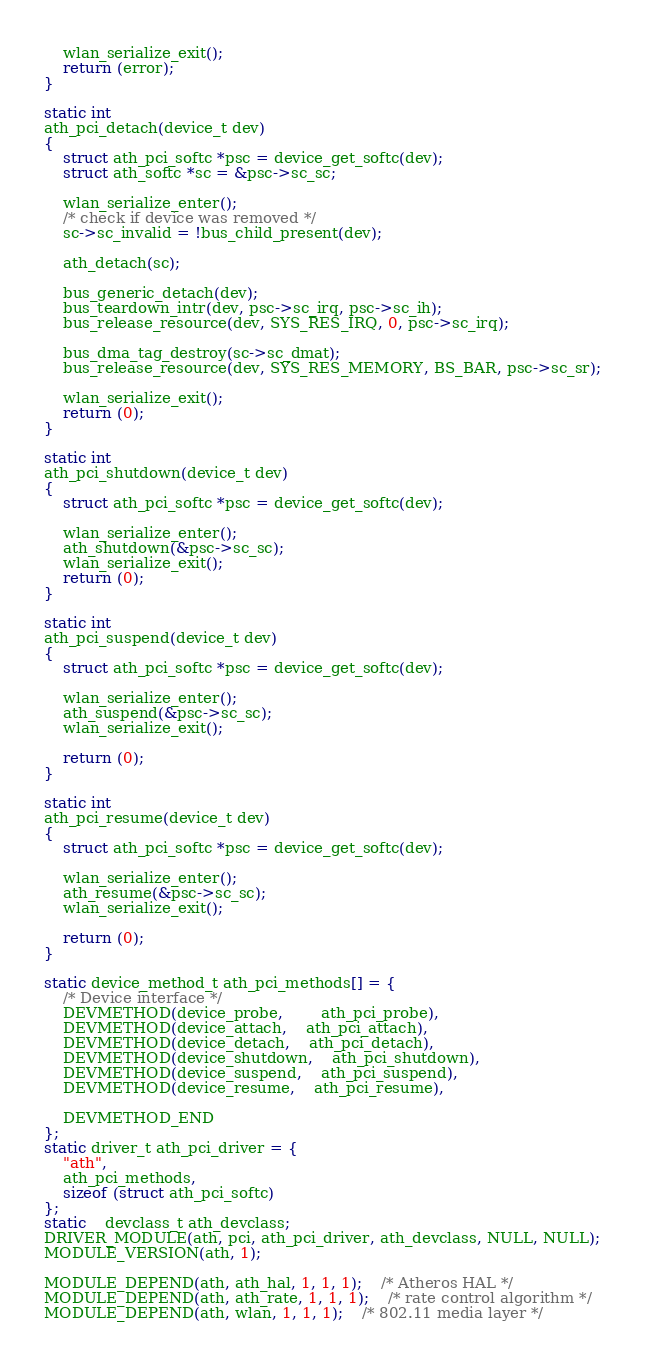Convert code to text. <code><loc_0><loc_0><loc_500><loc_500><_C_>	wlan_serialize_exit();
	return (error);
}

static int
ath_pci_detach(device_t dev)
{
	struct ath_pci_softc *psc = device_get_softc(dev);
	struct ath_softc *sc = &psc->sc_sc;

	wlan_serialize_enter();
	/* check if device was removed */
	sc->sc_invalid = !bus_child_present(dev);

	ath_detach(sc);

	bus_generic_detach(dev);
	bus_teardown_intr(dev, psc->sc_irq, psc->sc_ih);
	bus_release_resource(dev, SYS_RES_IRQ, 0, psc->sc_irq);

	bus_dma_tag_destroy(sc->sc_dmat);
	bus_release_resource(dev, SYS_RES_MEMORY, BS_BAR, psc->sc_sr);

	wlan_serialize_exit();
	return (0);
}

static int
ath_pci_shutdown(device_t dev)
{
	struct ath_pci_softc *psc = device_get_softc(dev);

	wlan_serialize_enter();
	ath_shutdown(&psc->sc_sc);
	wlan_serialize_exit();
	return (0);
}

static int
ath_pci_suspend(device_t dev)
{
	struct ath_pci_softc *psc = device_get_softc(dev);

	wlan_serialize_enter();
	ath_suspend(&psc->sc_sc);
	wlan_serialize_exit();

	return (0);
}

static int
ath_pci_resume(device_t dev)
{
	struct ath_pci_softc *psc = device_get_softc(dev);

	wlan_serialize_enter();
	ath_resume(&psc->sc_sc);
	wlan_serialize_exit();

	return (0);
}

static device_method_t ath_pci_methods[] = {
	/* Device interface */
	DEVMETHOD(device_probe,		ath_pci_probe),
	DEVMETHOD(device_attach,	ath_pci_attach),
	DEVMETHOD(device_detach,	ath_pci_detach),
	DEVMETHOD(device_shutdown,	ath_pci_shutdown),
	DEVMETHOD(device_suspend,	ath_pci_suspend),
	DEVMETHOD(device_resume,	ath_pci_resume),

	DEVMETHOD_END
};
static driver_t ath_pci_driver = {
	"ath",
	ath_pci_methods,
	sizeof (struct ath_pci_softc)
};
static	devclass_t ath_devclass;
DRIVER_MODULE(ath, pci, ath_pci_driver, ath_devclass, NULL, NULL);
MODULE_VERSION(ath, 1);

MODULE_DEPEND(ath, ath_hal, 1, 1, 1);	/* Atheros HAL */
MODULE_DEPEND(ath, ath_rate, 1, 1, 1);	/* rate control algorithm */
MODULE_DEPEND(ath, wlan, 1, 1, 1);	/* 802.11 media layer */
</code> 